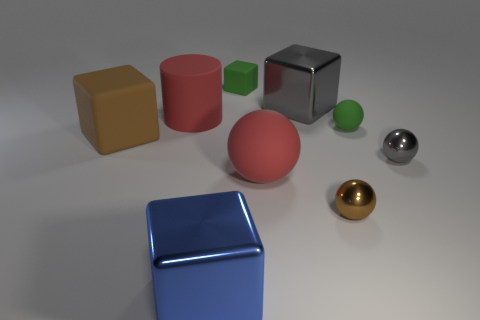Subtract all blocks. How many objects are left? 5 Subtract all red balls. How many balls are left? 3 Subtract all small blocks. How many blocks are left? 3 Subtract all green blocks. Subtract all green balls. How many blocks are left? 3 Subtract all cyan cubes. How many green spheres are left? 1 Subtract all small matte spheres. Subtract all yellow blocks. How many objects are left? 8 Add 1 small green rubber blocks. How many small green rubber blocks are left? 2 Add 4 tiny cyan balls. How many tiny cyan balls exist? 4 Subtract 1 red cylinders. How many objects are left? 8 Subtract 2 spheres. How many spheres are left? 2 